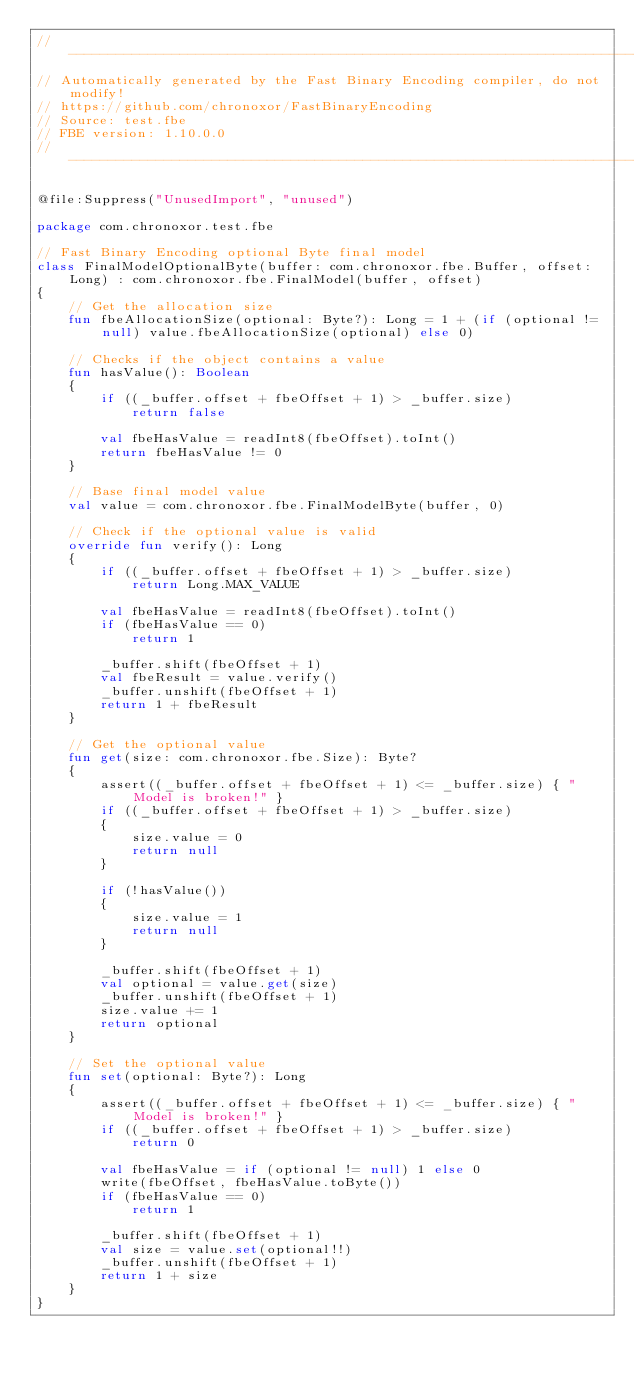<code> <loc_0><loc_0><loc_500><loc_500><_Kotlin_>//------------------------------------------------------------------------------
// Automatically generated by the Fast Binary Encoding compiler, do not modify!
// https://github.com/chronoxor/FastBinaryEncoding
// Source: test.fbe
// FBE version: 1.10.0.0
//------------------------------------------------------------------------------

@file:Suppress("UnusedImport", "unused")

package com.chronoxor.test.fbe

// Fast Binary Encoding optional Byte final model
class FinalModelOptionalByte(buffer: com.chronoxor.fbe.Buffer, offset: Long) : com.chronoxor.fbe.FinalModel(buffer, offset)
{
    // Get the allocation size
    fun fbeAllocationSize(optional: Byte?): Long = 1 + (if (optional != null) value.fbeAllocationSize(optional) else 0)

    // Checks if the object contains a value
    fun hasValue(): Boolean
    {
        if ((_buffer.offset + fbeOffset + 1) > _buffer.size)
            return false

        val fbeHasValue = readInt8(fbeOffset).toInt()
        return fbeHasValue != 0
    }

    // Base final model value
    val value = com.chronoxor.fbe.FinalModelByte(buffer, 0)

    // Check if the optional value is valid
    override fun verify(): Long
    {
        if ((_buffer.offset + fbeOffset + 1) > _buffer.size)
            return Long.MAX_VALUE

        val fbeHasValue = readInt8(fbeOffset).toInt()
        if (fbeHasValue == 0)
            return 1

        _buffer.shift(fbeOffset + 1)
        val fbeResult = value.verify()
        _buffer.unshift(fbeOffset + 1)
        return 1 + fbeResult
    }

    // Get the optional value
    fun get(size: com.chronoxor.fbe.Size): Byte?
    {
        assert((_buffer.offset + fbeOffset + 1) <= _buffer.size) { "Model is broken!" }
        if ((_buffer.offset + fbeOffset + 1) > _buffer.size)
        {
            size.value = 0
            return null
        }

        if (!hasValue())
        {
            size.value = 1
            return null
        }

        _buffer.shift(fbeOffset + 1)
        val optional = value.get(size)
        _buffer.unshift(fbeOffset + 1)
        size.value += 1
        return optional
    }

    // Set the optional value
    fun set(optional: Byte?): Long
    {
        assert((_buffer.offset + fbeOffset + 1) <= _buffer.size) { "Model is broken!" }
        if ((_buffer.offset + fbeOffset + 1) > _buffer.size)
            return 0

        val fbeHasValue = if (optional != null) 1 else 0
        write(fbeOffset, fbeHasValue.toByte())
        if (fbeHasValue == 0)
            return 1

        _buffer.shift(fbeOffset + 1)
        val size = value.set(optional!!)
        _buffer.unshift(fbeOffset + 1)
        return 1 + size
    }
}
</code> 